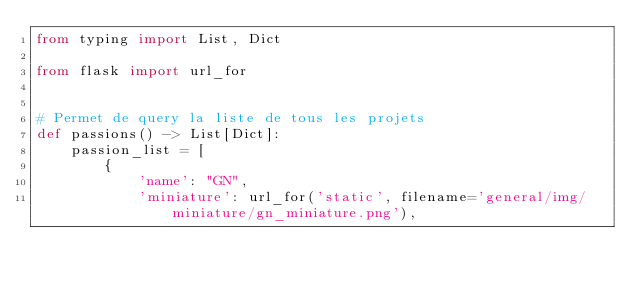<code> <loc_0><loc_0><loc_500><loc_500><_Python_>from typing import List, Dict

from flask import url_for


# Permet de query la liste de tous les projets
def passions() -> List[Dict]:
    passion_list = [
        {
            'name': "GN",
            'miniature': url_for('static', filename='general/img/miniature/gn_miniature.png'),</code> 